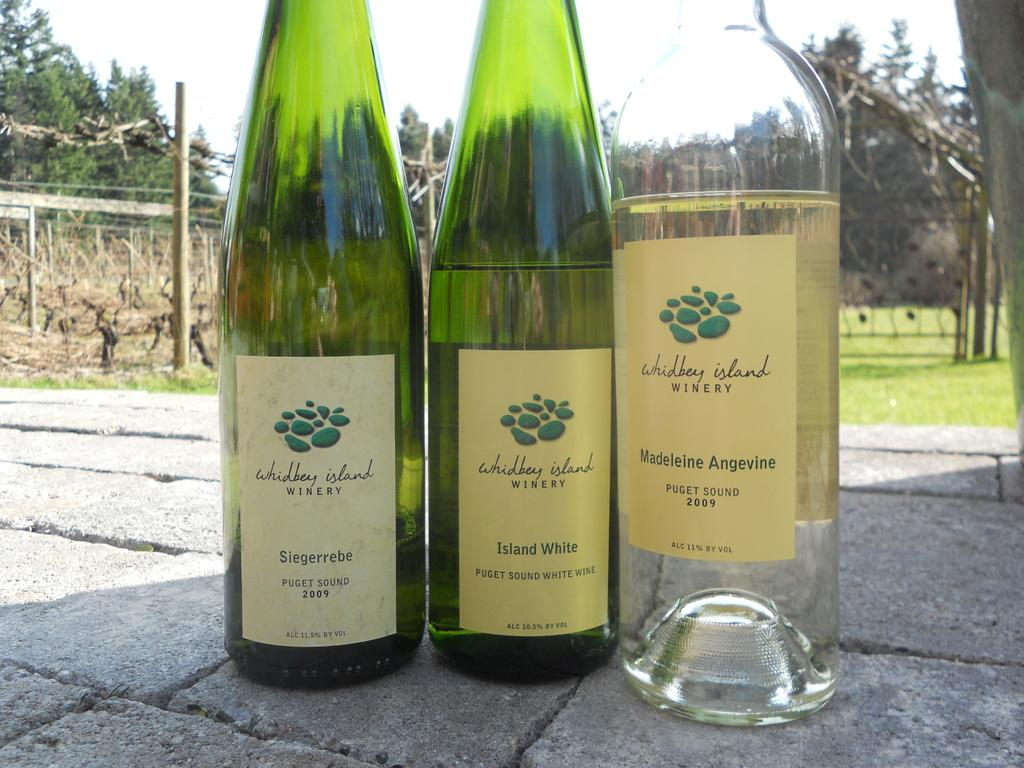Provide a one-sentence caption for the provided image. Three bottles of wine labelled as made by whidbey Island stand side by side in a sunny setting. 